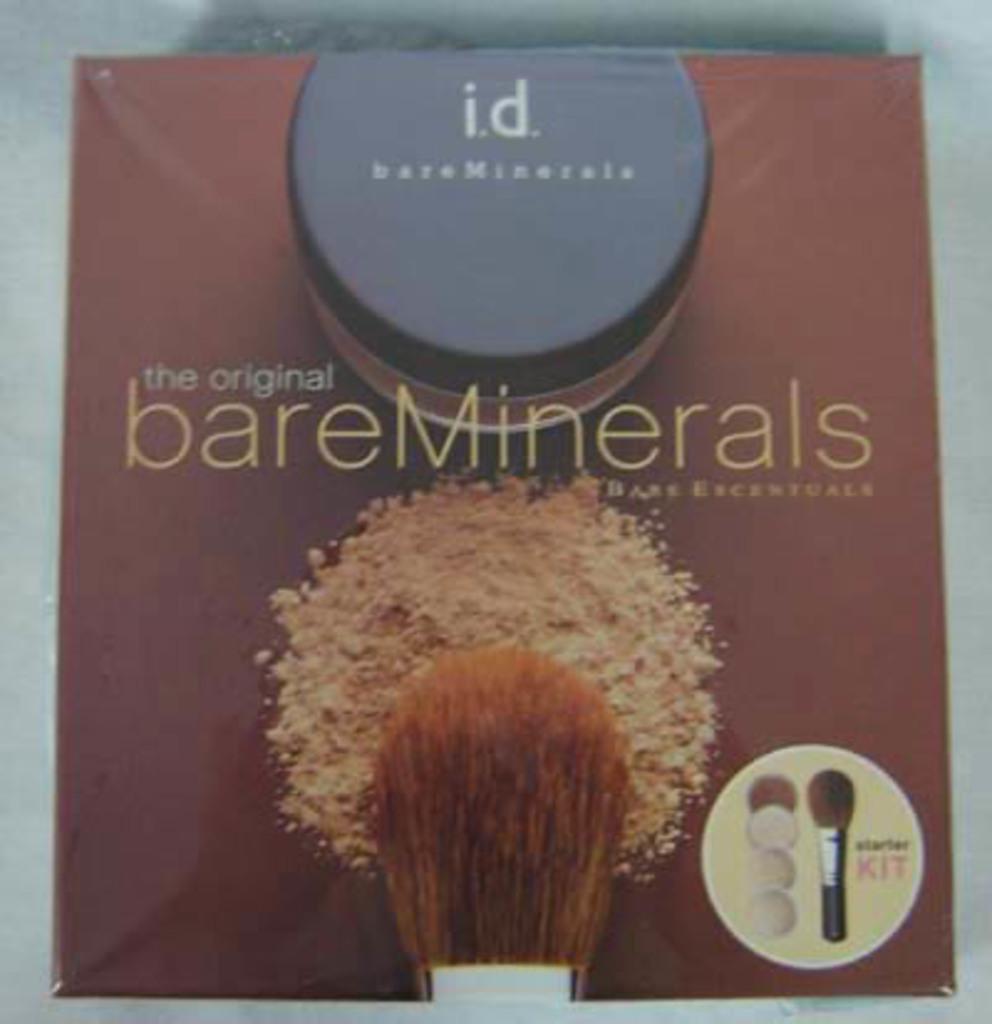What is inside the box?
Make the answer very short. Bare minerals. What brand is this makeup?
Ensure brevity in your answer.  Bareminerals. 